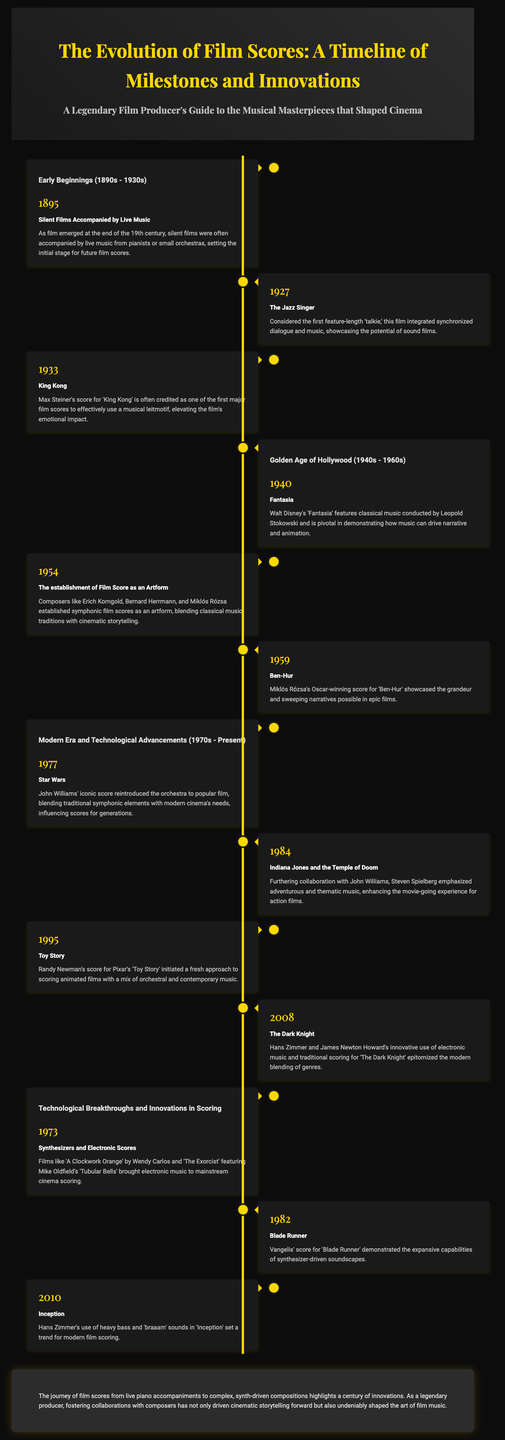what year did silent films begin to be accompanied by live music? The document states that silent films were accompanied by live music starting in 1895.
Answer: 1895 who composed the score for King Kong? The document mentions that Max Steiner composed the score for 'King Kong.'
Answer: Max Steiner what significant film was released in 1927? The document highlights 'The Jazz Singer' as the first feature-length 'talkie' released in 1927.
Answer: The Jazz Singer what element did John Williams' score for Star Wars reintroduce? The score for 'Star Wars' reintroduced the orchestra to popular film.
Answer: Orchestra which film is noted for pioneering animated film scoring in 1995? The document describes 'Toy Story' as the film that initiated a fresh approach to scoring animated films in 1995.
Answer: Toy Story what innovation in film scoring occurred in 1973? The document states that synthesizers and electronic scores were introduced in 1973.
Answer: Synthesizers and Electronic Scores how did film scoring evolve in the Golden Age of Hollywood according to the document? The document explains that composers established symphonic film scores as an artform during the Golden Age.
Answer: Symphonic film scores as an artform what is a notable characteristic of the score for Inception released in 2010? The document notes Hans Zimmer's use of heavy bass and 'braaam' sounds in 'Inception.'
Answer: Heavy bass and 'braaam' sounds what color accentuates the timeline in the document? The timeline is accentuated by the color gold as noted throughout the document.
Answer: Gold 